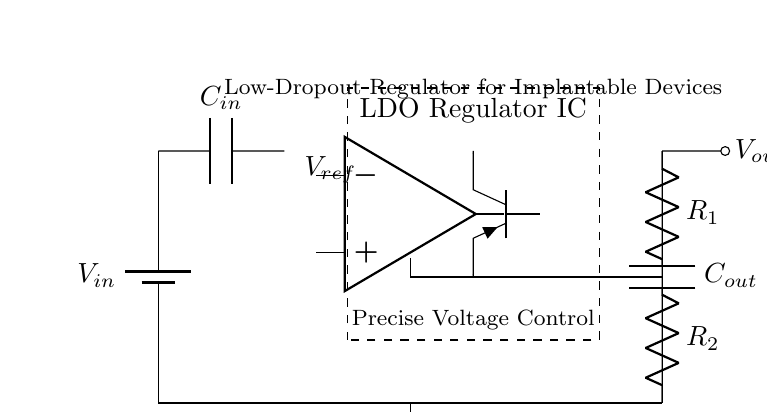What is the role of the capacitor labeled as C in the diagram? The capacitor labeled as C in the circuit is used for filtering and stabilizing the voltage output. It smooths the output voltage by reducing voltage ripple and maintaining a stable output during transient loads.
Answer: Filtering and stabilizing output What is the reference voltage in this circuit? By visual inspection, the reference voltage, indicated by V ref, is typically a fixed value in the circuit. However, the exact number is not specified in the provided diagram.
Answer: Not specified How many resistors are present in the feedback network? There are two resistors, R one and R two, in the feedback network, which are important for setting the output voltage based on the voltage divider principle.
Answer: Two What type of transistors does the circuit use to control the output voltage? The circuit utilizes a PNP type transistor labeled Tpnp to manage the power regulation in a low-dropout manner, allowing for lower input-output voltage differentials.
Answer: PNP What is the function of the operational amplifier in this circuit? The operational amplifier serves as an error amplifier, comparing the output voltage to the reference voltage and adjusting the pass transistor accordingly to maintain precise output voltage regulation.
Answer: Error amplifier 